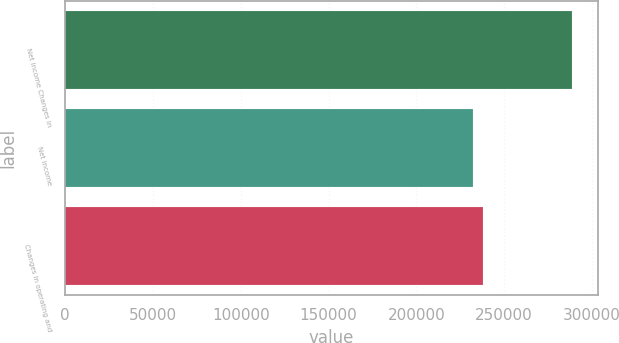Convert chart to OTSL. <chart><loc_0><loc_0><loc_500><loc_500><bar_chart><fcel>Net income Changes in<fcel>Net income<fcel>Changes in operating and<nl><fcel>288979<fcel>232306<fcel>237973<nl></chart> 